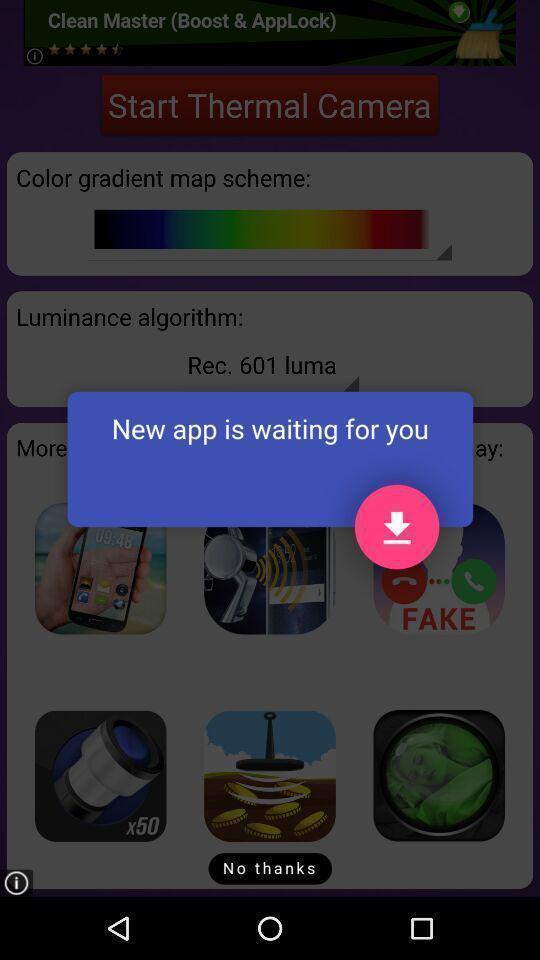Provide a description of this screenshot. Pop-up showing to download new app. 